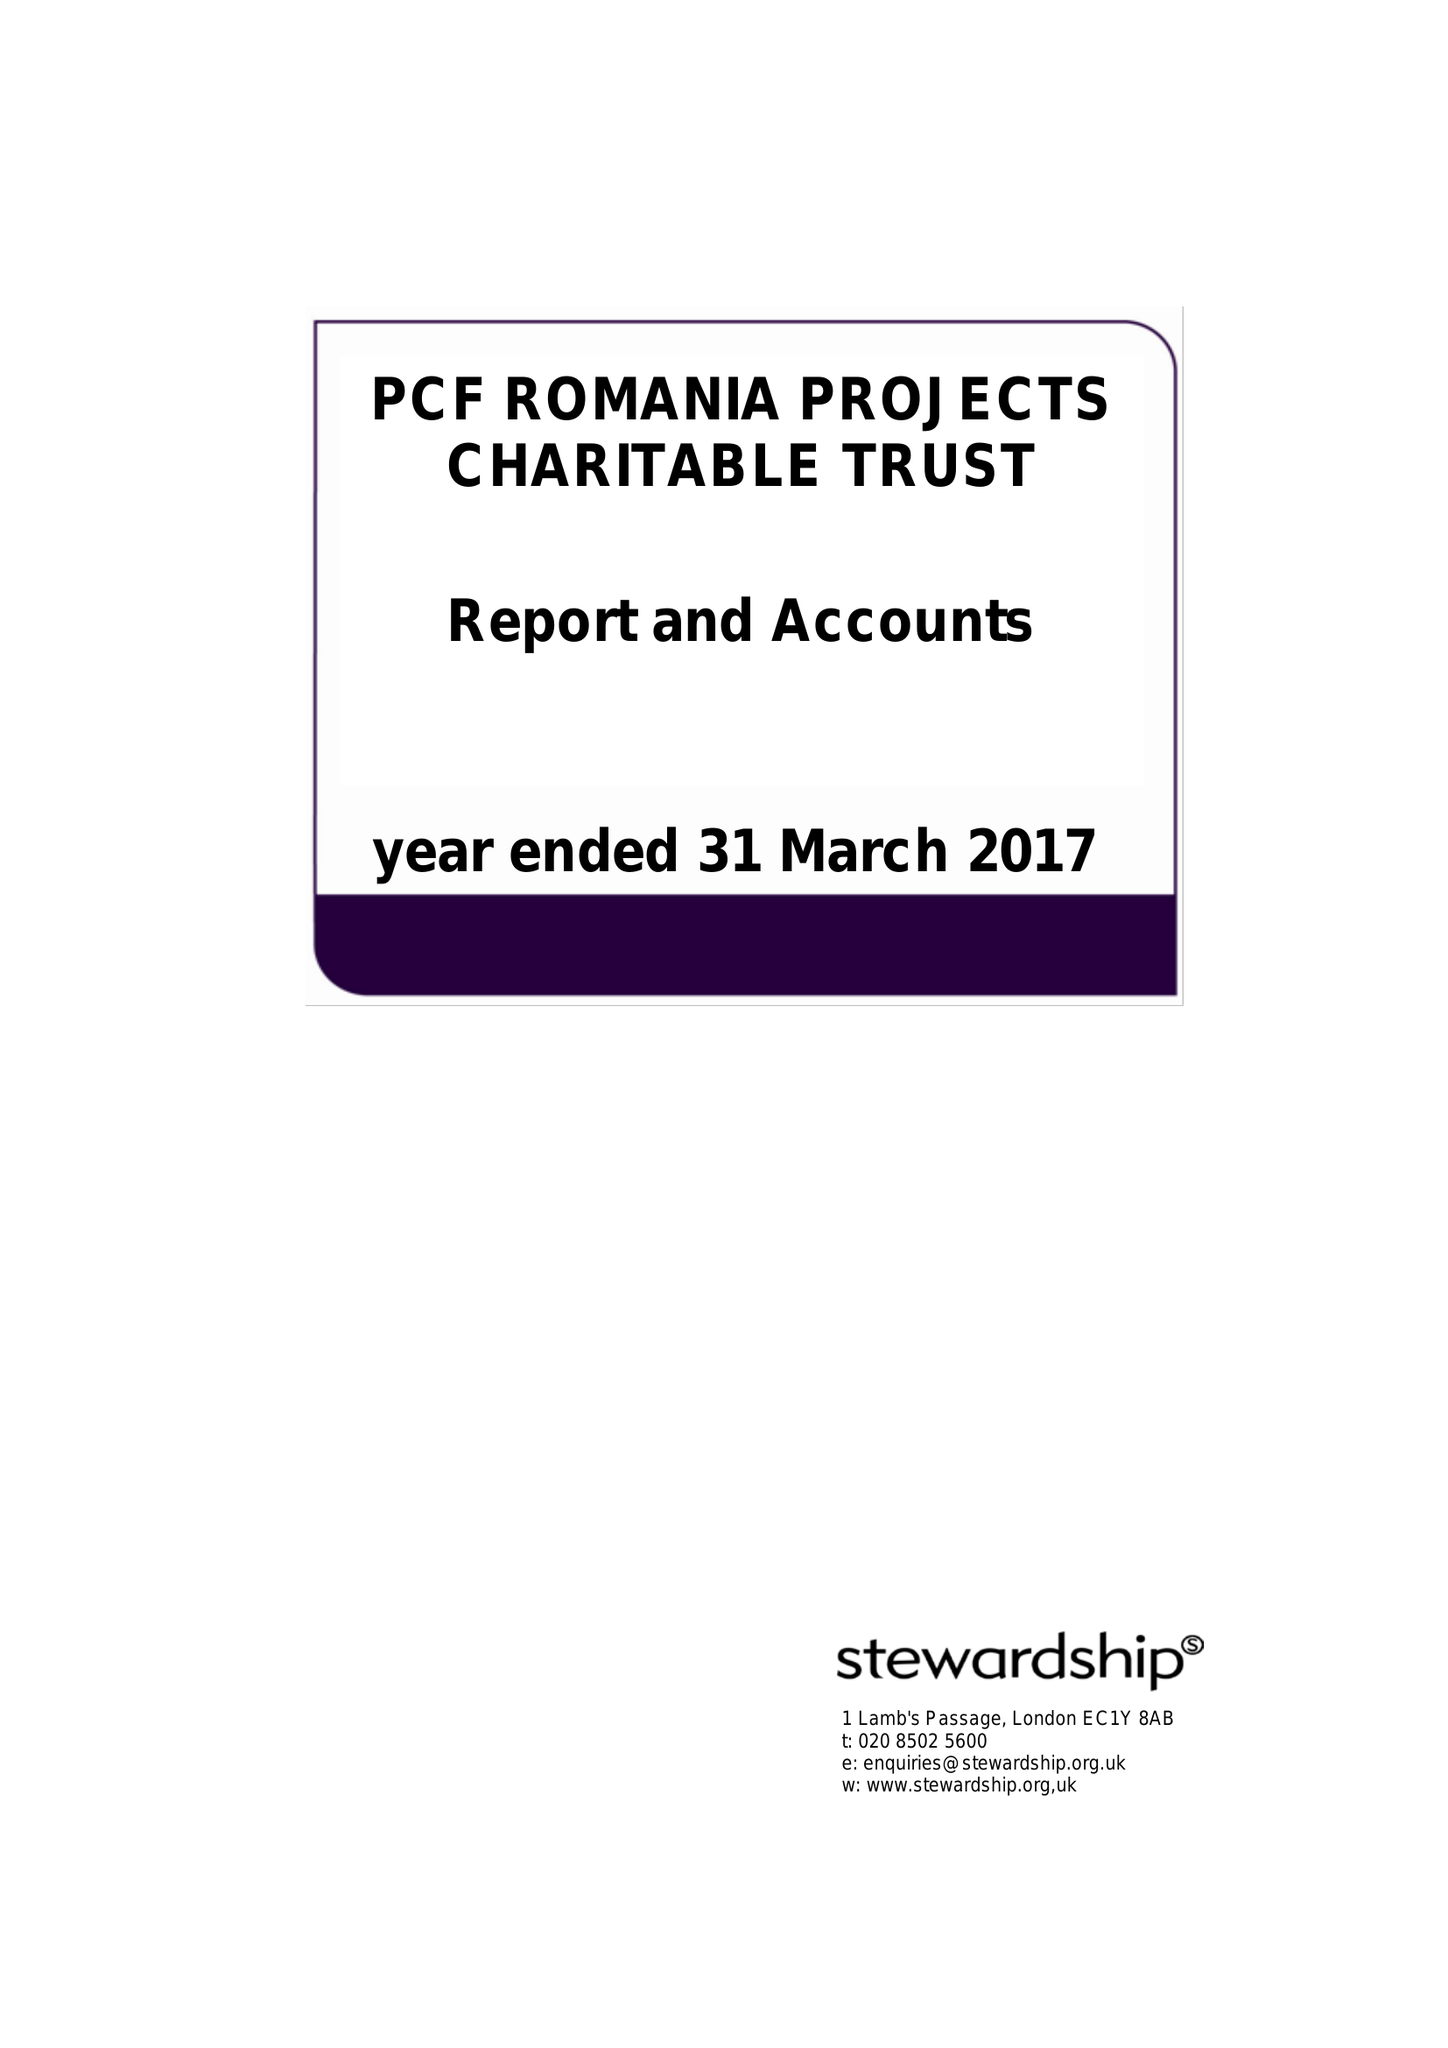What is the value for the charity_name?
Answer the question using a single word or phrase. Pcf Romania Projects Charitable Trust 